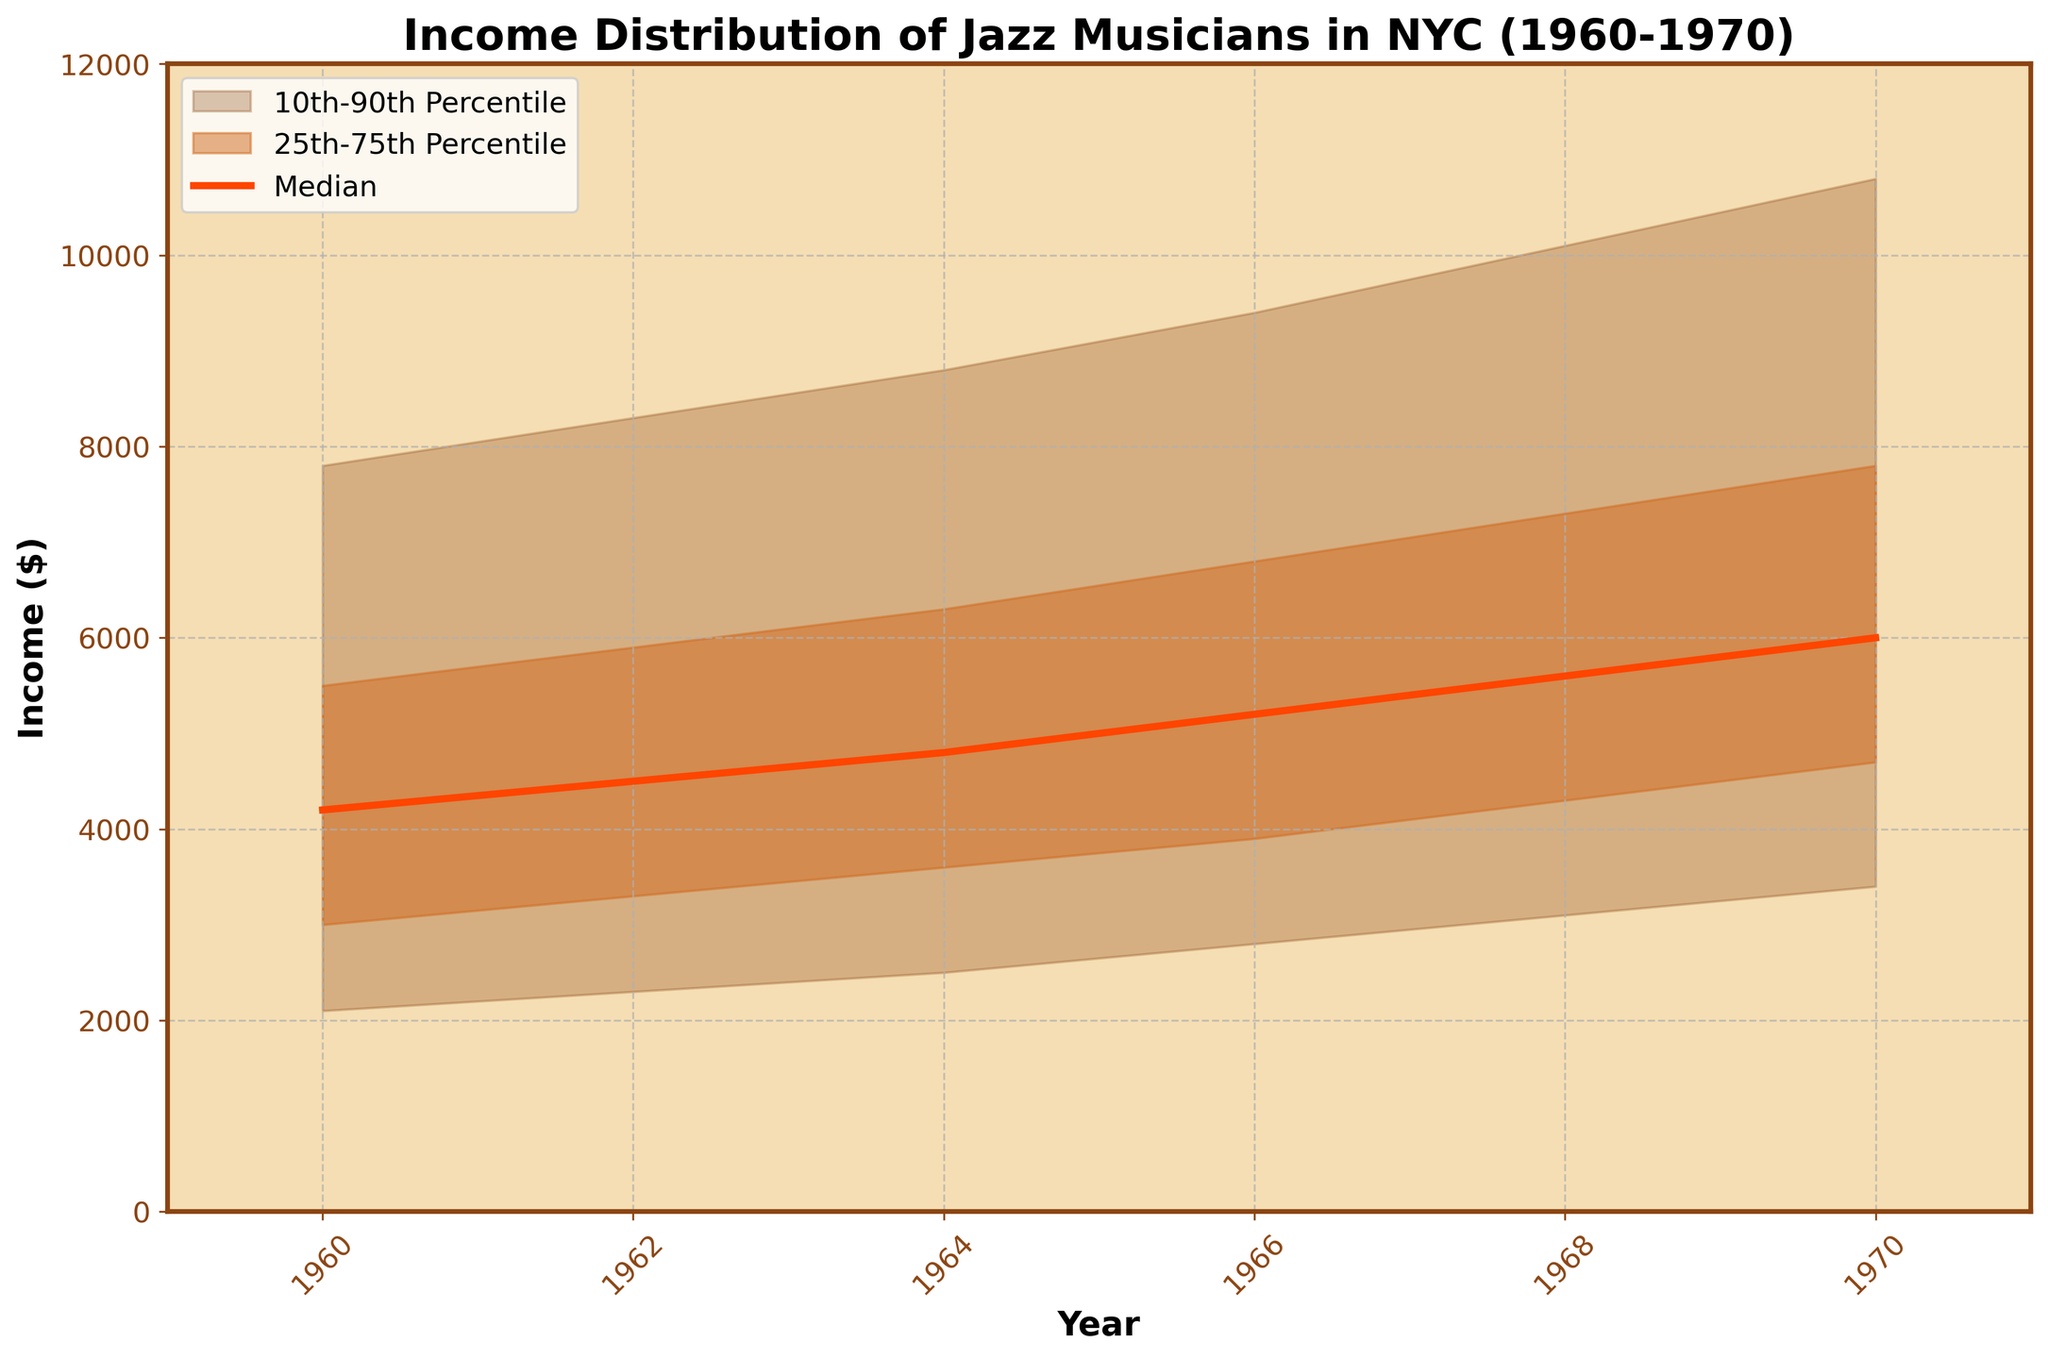What is the title of the chart? Look at the top of the chart; the title provides a summary of the plot's content.
Answer: Income Distribution of Jazz Musicians in NYC (1960-1970) What is the median income of jazz musicians in 1966? Identify the year 1966 on the x-axis, then trace vertically to the median line and read the value on the y-axis.
Answer: $5200 Which range of incomes is represented by the lighter brown shaded area? The lighter brown area represents the range from the 10th percentile to the 90th percentile.
Answer: 10th-90th Percentile How does the median income in 1962 compare to the median income in 1970? Examine the median line at 1962 and 1970, and compare their y-axis values to see the increase or decrease.
Answer: Increased What is the difference in income between the 75th percentile and the 25th percentile in 1968? Find the 75th and 25th percentile values for 1968 and subtract the 25th percentile from the 75th percentile to find the difference.
Answer: $3000 What trend do you observe in the median income of jazz musicians from 1960 to 1970? Follow the median income line from 1960 to 1970 and describe the general direction, whether increasing, decreasing, or constant.
Answer: Increasing By how much did the income at the 10th percentile increase from 1960 to 1970? Identify the 10th percentile income in 1960 and 1970 and subtract the 1960 value from the 1970 value.
Answer: $1300 Which year saw the highest income at the 90th percentile? Look at the values on the upper boundary of the lighter brown area (90th percentile) and find the maximum income, then identify the corresponding year.
Answer: 1970 Compare the spread between the 10th and 90th percentiles in 1960 and 1970. How has it changed? Measure the difference between the 10th and 90th percentiles for both years and compare the differences.
Answer: Increased What was the income at the 25th percentile in 1964, and how does it relate to the median income in 1960? Find the 25th percentile value for 1964 and the median for 1960, then compare these values.
Answer: Higher 